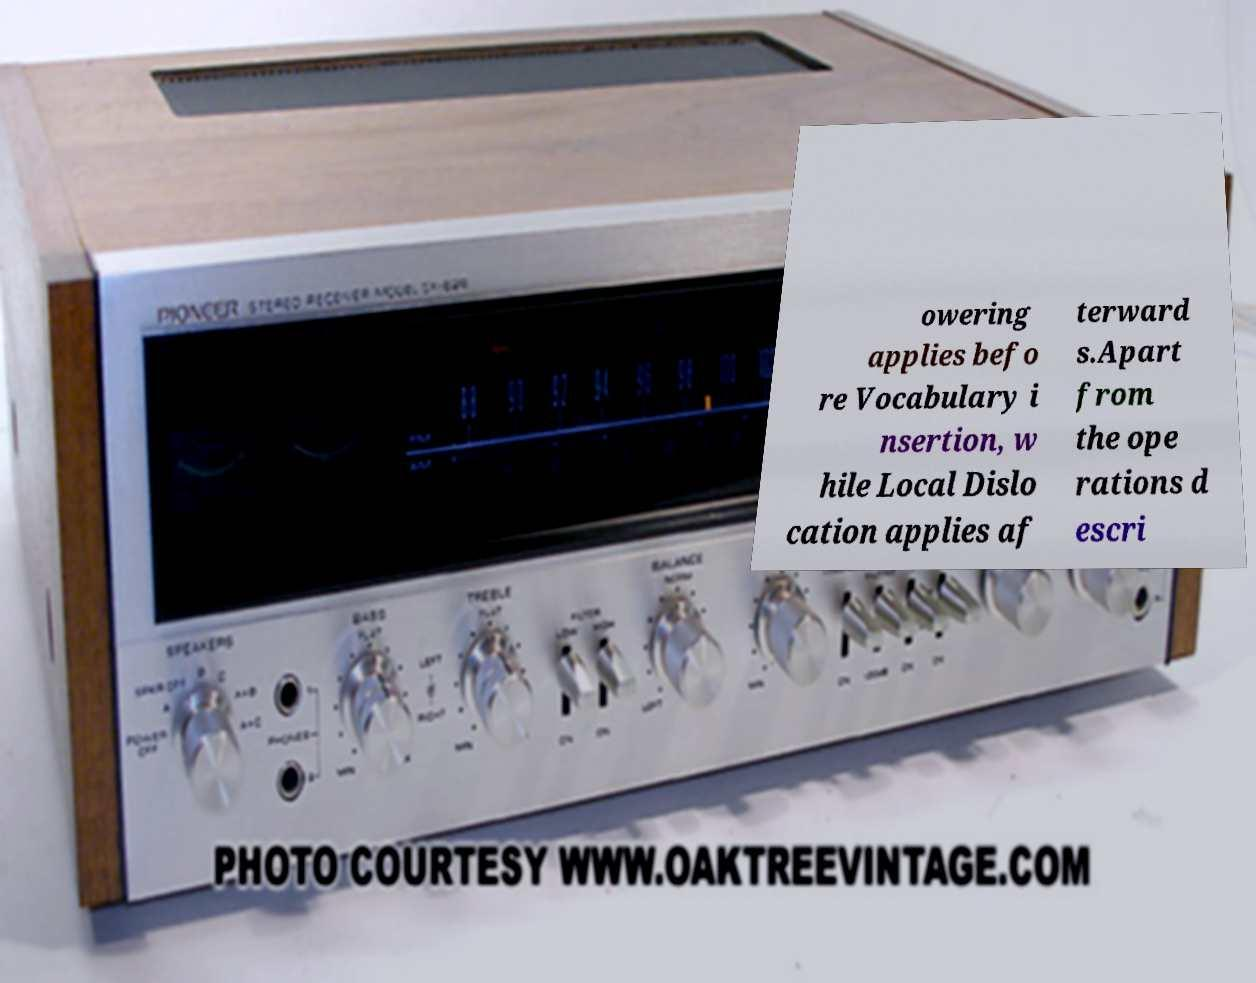Please identify and transcribe the text found in this image. owering applies befo re Vocabulary i nsertion, w hile Local Dislo cation applies af terward s.Apart from the ope rations d escri 